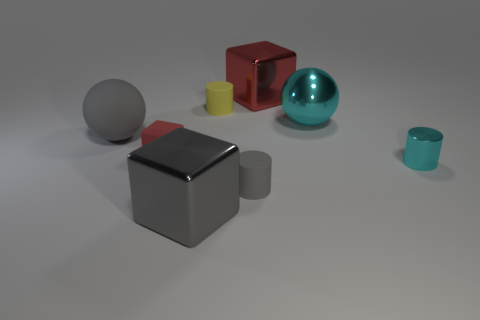What is the material of the tiny yellow object that is the same shape as the tiny cyan metallic thing?
Provide a short and direct response. Rubber. Is the shape of the small gray rubber object the same as the yellow thing?
Provide a succinct answer. Yes. There is a cylinder that is the same color as the rubber ball; what material is it?
Offer a terse response. Rubber. What shape is the tiny object that is the same material as the big gray block?
Your answer should be compact. Cylinder. What color is the large metallic object that is in front of the small cyan cylinder?
Offer a terse response. Gray. What number of things are metallic things that are to the right of the yellow matte cylinder or small metallic things that are to the right of the matte ball?
Offer a very short reply. 3. Do the gray block and the gray sphere have the same size?
Offer a very short reply. Yes. How many cubes are big green rubber things or small gray objects?
Provide a succinct answer. 0. What number of small objects are behind the tiny gray cylinder and in front of the small red rubber thing?
Provide a succinct answer. 1. There is a red shiny object; does it have the same size as the red object that is in front of the big red object?
Provide a succinct answer. No. 